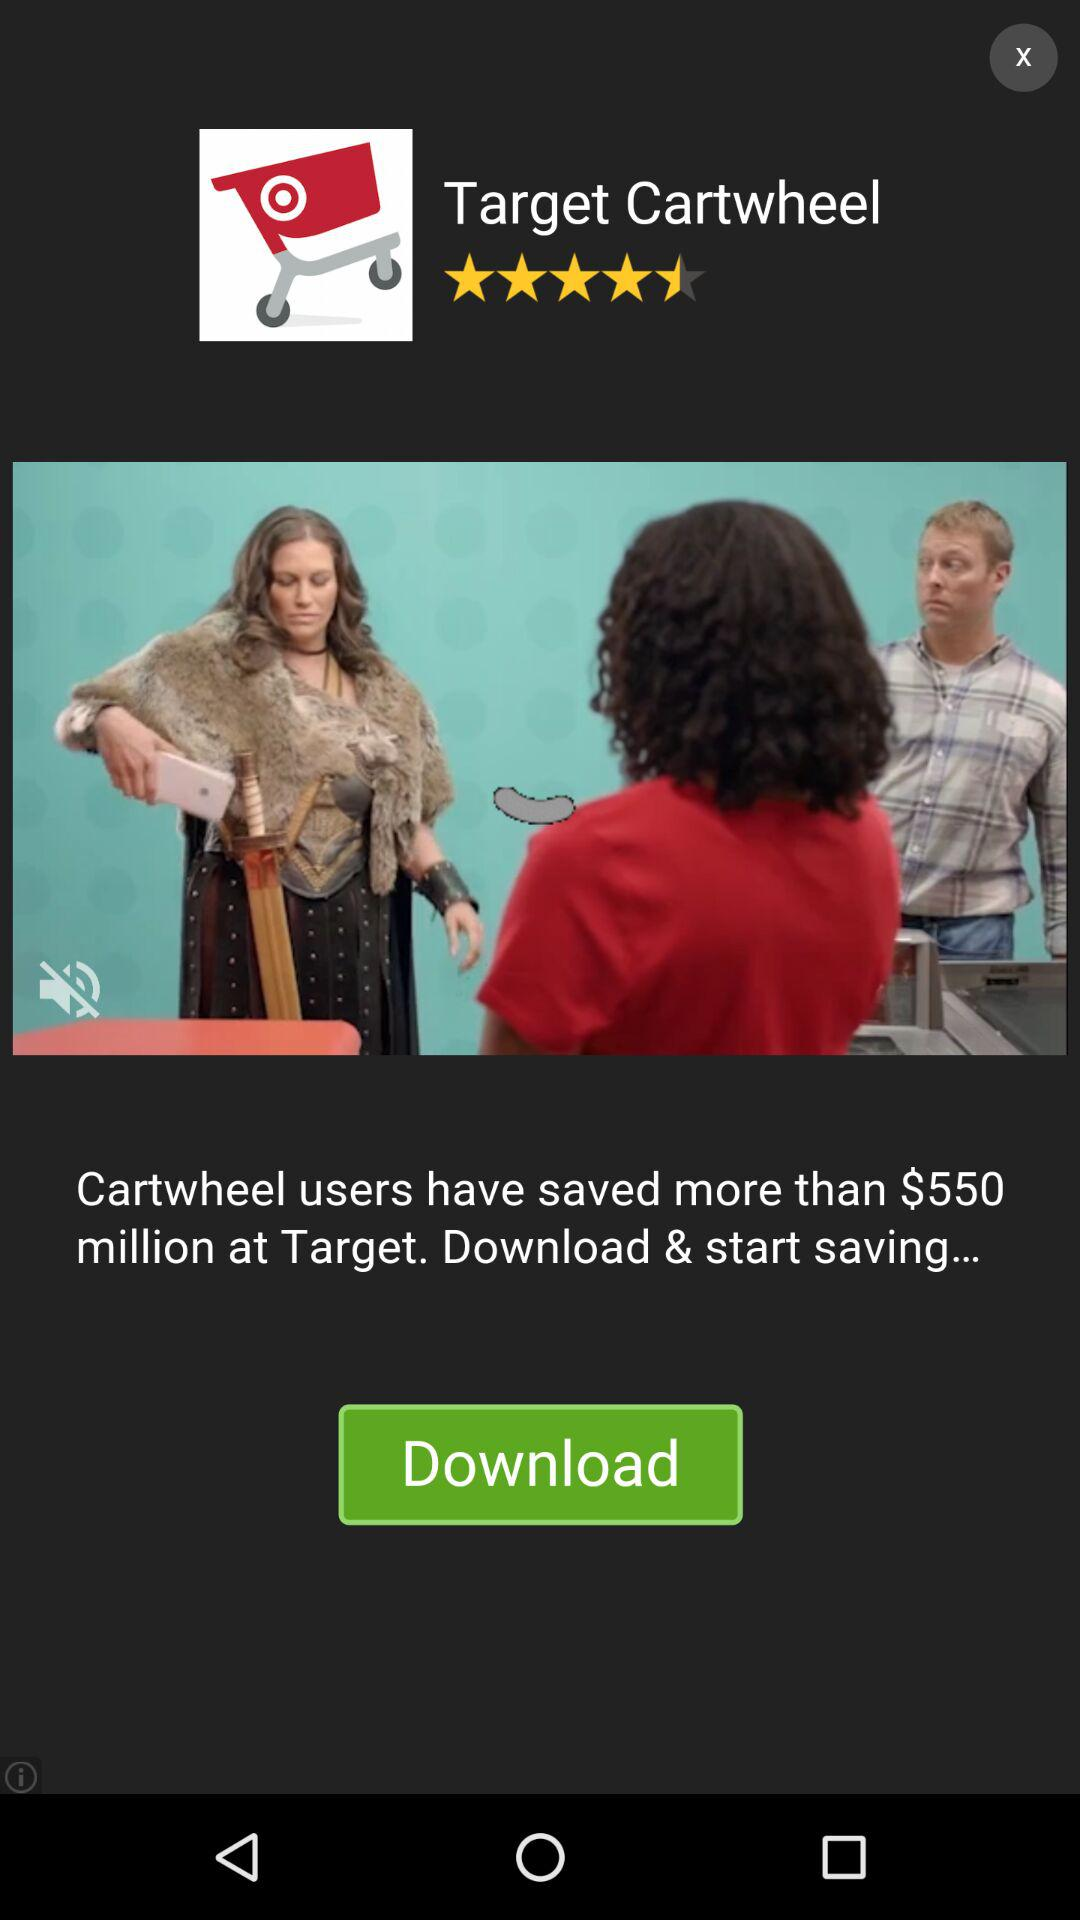How much money have Cartwheel users saved at Target?
Answer the question using a single word or phrase. $550 million 